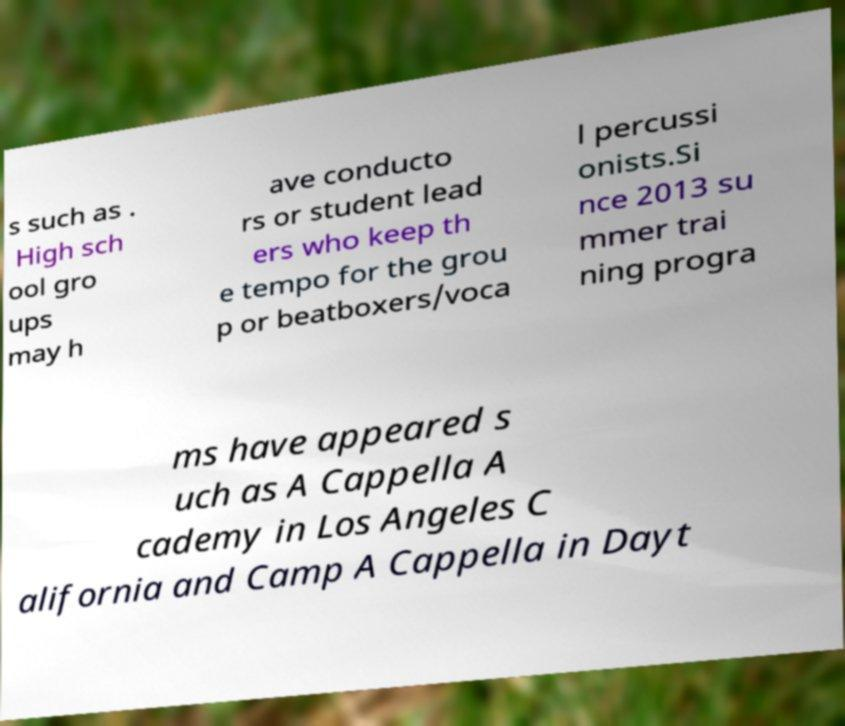Please identify and transcribe the text found in this image. s such as . High sch ool gro ups may h ave conducto rs or student lead ers who keep th e tempo for the grou p or beatboxers/voca l percussi onists.Si nce 2013 su mmer trai ning progra ms have appeared s uch as A Cappella A cademy in Los Angeles C alifornia and Camp A Cappella in Dayt 